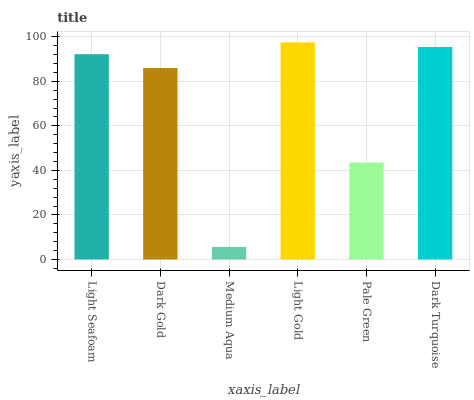Is Dark Gold the minimum?
Answer yes or no. No. Is Dark Gold the maximum?
Answer yes or no. No. Is Light Seafoam greater than Dark Gold?
Answer yes or no. Yes. Is Dark Gold less than Light Seafoam?
Answer yes or no. Yes. Is Dark Gold greater than Light Seafoam?
Answer yes or no. No. Is Light Seafoam less than Dark Gold?
Answer yes or no. No. Is Light Seafoam the high median?
Answer yes or no. Yes. Is Dark Gold the low median?
Answer yes or no. Yes. Is Medium Aqua the high median?
Answer yes or no. No. Is Light Gold the low median?
Answer yes or no. No. 